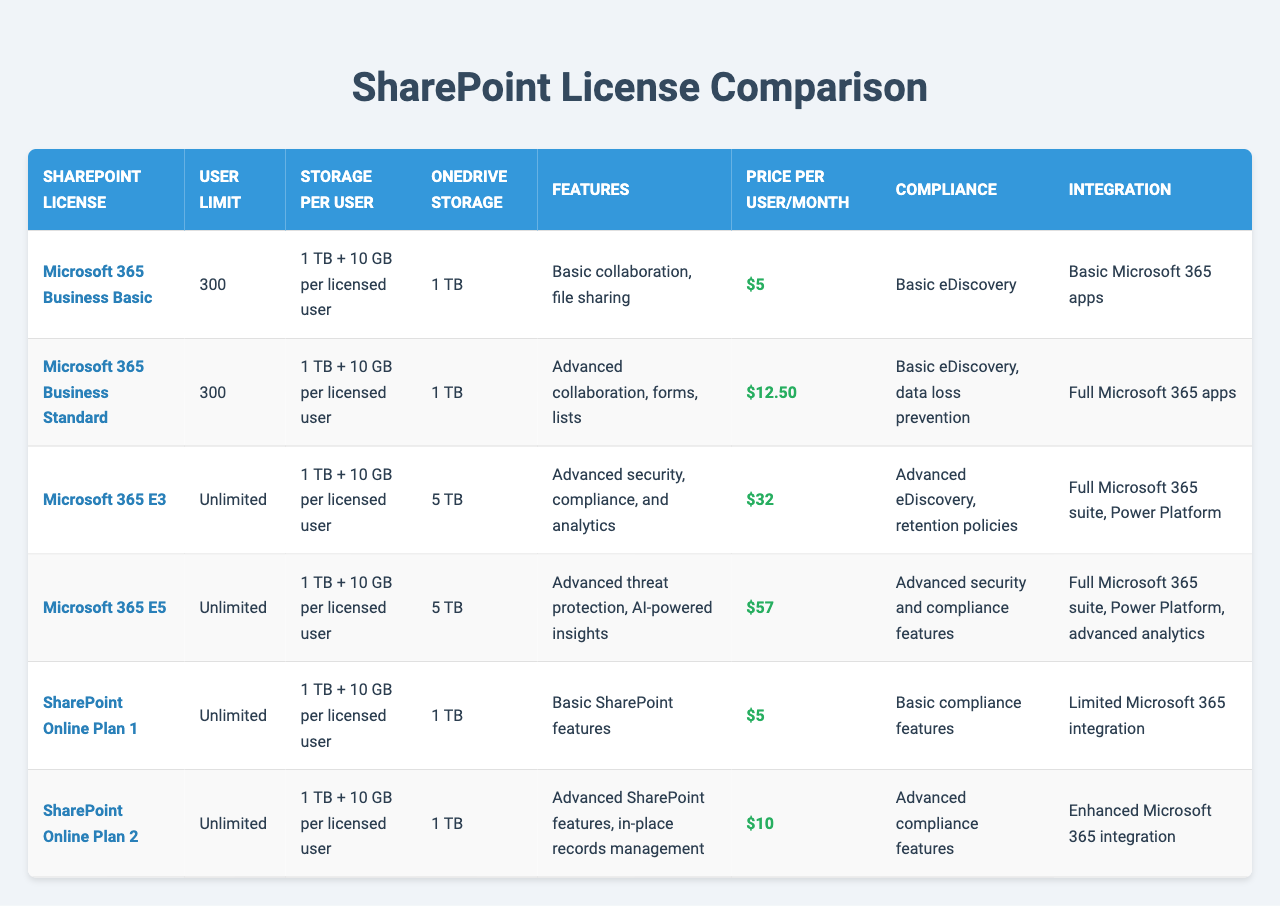What is the price per user per month for Microsoft 365 E3? The price for Microsoft 365 E3 is listed in the table under the "Price per User/Month" column. It shows a price of $32.
Answer: $32 How much OneDrive storage do users get with Microsoft 365 Business Standard? The "OneDrive Storage" column shows 1 TB for Microsoft 365 Business Standard.
Answer: 1 TB Is there a user limit for SharePoint Online Plan 1? The "User Limit" for SharePoint Online Plan 1 is listed as "Unlimited" in the table.
Answer: Yes What is the total storage per user for Microsoft 365 E5, including the additional storage? The storage per user for Microsoft 365 E5 is stated as "1 TB + 10 GB per licensed user." This means that each user gets 1 TB of storage plus an additional 10 GB.
Answer: 1 TB + 10 GB Which SharePoint license has the most advanced compliance features? The compliance features column shows that Microsoft 365 E5 has "Advanced security and compliance features," which is more advanced compared to other licenses listed.
Answer: Microsoft 365 E5 What is the price difference between Microsoft 365 Business Basic and SharePoint Online Plan 2? Microsoft 365 Business Basic costs $5, while SharePoint Online Plan 2 costs $10. The difference is calculated as $10 - $5 = $5.
Answer: $5 Are there any licenses with unlimited user limits that include advanced collaboration features? Yes, both Microsoft 365 E3 and E5 have unlimited user limits and include advanced collaboration features.
Answer: Yes Which license offers the highest OneDrive storage capacity? By examining the "OneDrive Storage" column, it is clear that Microsoft 365 E3 and E5 both provide 5 TB, which is more than the other licenses.
Answer: Microsoft 365 E3 and E5 If the company has 150 users and adopts Microsoft 365 Business Standard, what will be the total monthly cost? The price per user per month for Microsoft 365 Business Standard is $12.50. Total cost for 150 users would be calculated as 150 * $12.50 = $1,875.
Answer: $1,875 Do all Microsoft 365 licenses offer the same amount of storage per user? No, while all licenses have "1 TB + 10 GB" storage per user, only Microsoft 365 E3 and E5 offer different OneDrive storage amounts (5 TB).
Answer: No 